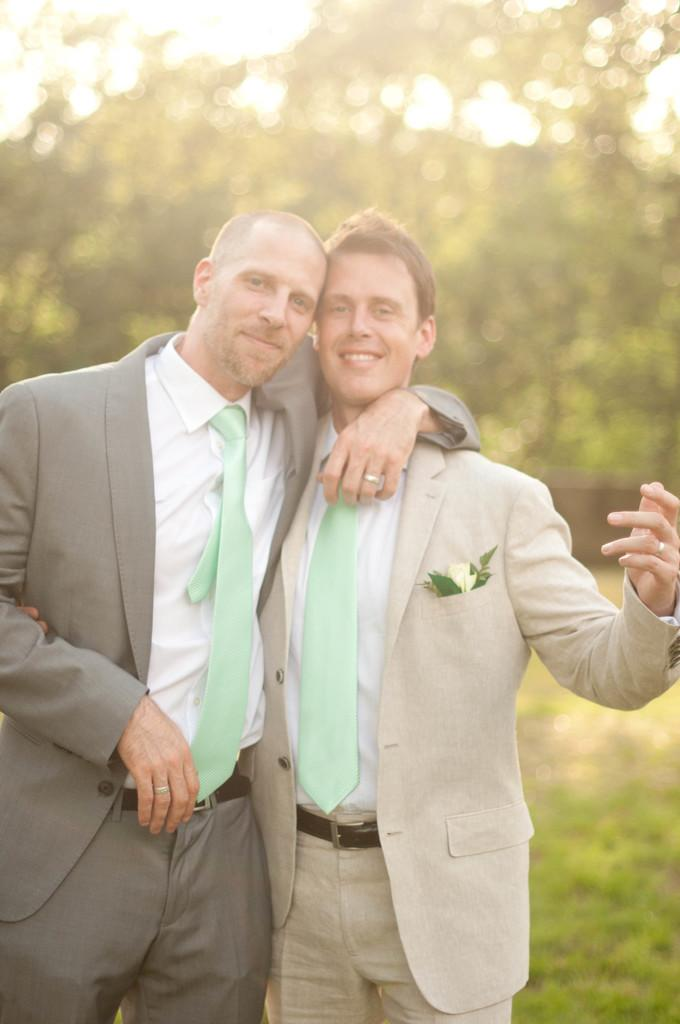How many people are in the foreground of the image? There are two persons standing in the foreground. What is the surface they are standing on? The persons are standing on grass. What can be seen in the background of the image? There are trees and the sky visible in the background. Can you describe the setting where the image might have been taken? The image might have been taken in a park, given the presence of grass and trees. What type of boundary can be seen in the image? There is no boundary visible in the image. What type of laborer is working in the background of the image? There are no laborers present in the image; it features two persons standing on grass and a background with trees and the sky. 